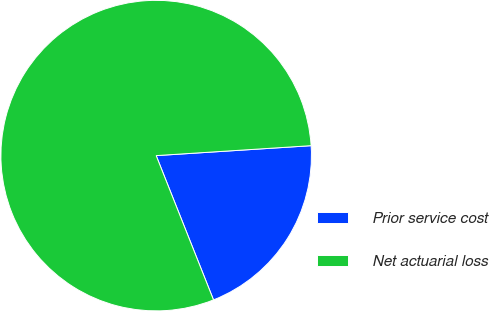<chart> <loc_0><loc_0><loc_500><loc_500><pie_chart><fcel>Prior service cost<fcel>Net actuarial loss<nl><fcel>20.0%<fcel>80.0%<nl></chart> 